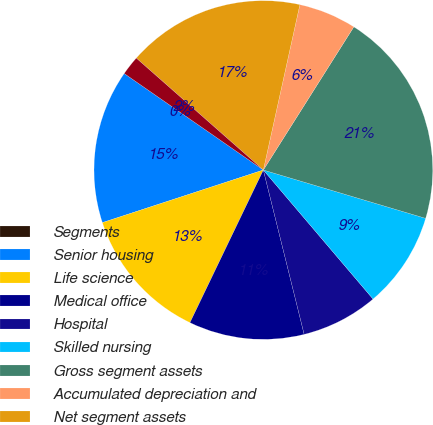<chart> <loc_0><loc_0><loc_500><loc_500><pie_chart><fcel>Segments<fcel>Senior housing<fcel>Life science<fcel>Medical office<fcel>Hospital<fcel>Skilled nursing<fcel>Gross segment assets<fcel>Accumulated depreciation and<fcel>Net segment assets<fcel>Real estate held for sale net<nl><fcel>0.0%<fcel>14.68%<fcel>12.84%<fcel>11.01%<fcel>7.34%<fcel>9.18%<fcel>20.64%<fcel>5.51%<fcel>16.97%<fcel>1.84%<nl></chart> 